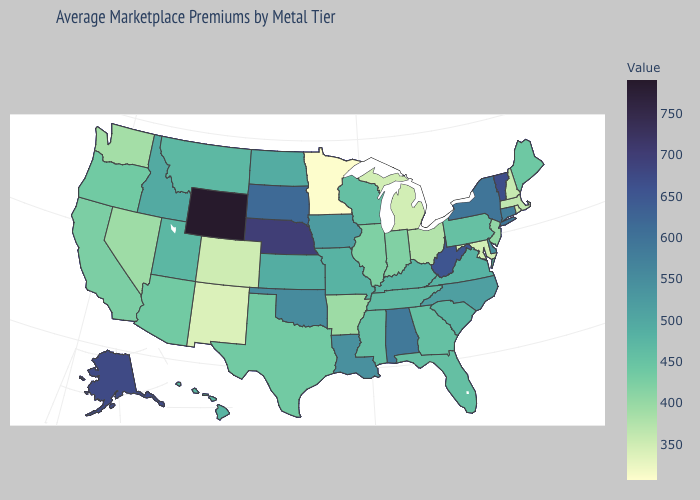Does Maryland have a lower value than Oregon?
Keep it brief. Yes. Is the legend a continuous bar?
Give a very brief answer. Yes. Which states have the lowest value in the MidWest?
Be succinct. Minnesota. Among the states that border Nevada , which have the highest value?
Give a very brief answer. Idaho. Does the map have missing data?
Be succinct. No. 